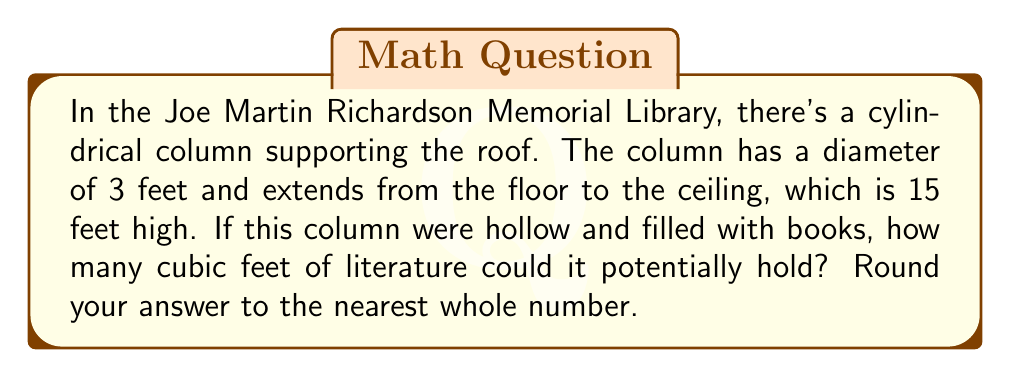Show me your answer to this math problem. To solve this problem, we need to calculate the volume of a cylinder. The formula for the volume of a cylinder is:

$$ V = \pi r^2 h $$

Where:
$V$ = volume
$r$ = radius of the base
$h$ = height of the cylinder

Given:
- Diameter = 3 feet
- Height = 15 feet

Step 1: Calculate the radius
The radius is half the diameter:
$$ r = \frac{3}{2} = 1.5 \text{ feet} $$

Step 2: Apply the volume formula
$$ V = \pi (1.5)^2 (15) $$

Step 3: Calculate
$$ V = \pi (2.25) (15) $$
$$ V = 33.75\pi $$

Step 4: Evaluate and round to the nearest whole number
$$ V \approx 106.03 \text{ cubic feet} $$
Rounded to the nearest whole number: 106 cubic feet

[asy]
import geometry;

size(200);
real r = 1.5;
real h = 15/3;  // Scaled down for better visualization

path base = circle((0,0), r);
path top = circle((0,h), r);

draw(base);
draw(top);
draw((r,0)--(r,h));
draw((-r,0)--(-r,h));

label("3 ft", (r,h/2), E);
label("15 ft", (r+0.5,h/2), E);

draw((0,0)--(r,0), arrow=Arrow(TeXHead));
label("1.5 ft", (r/2,0), S);
</asy]
Answer: 106 cubic feet 